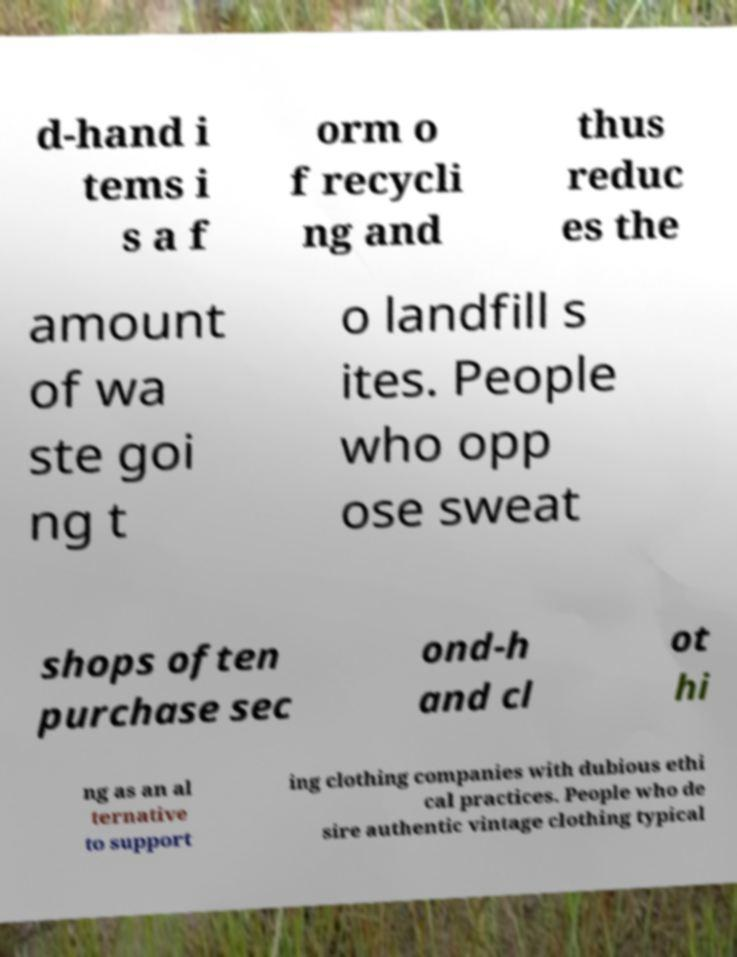Please identify and transcribe the text found in this image. d-hand i tems i s a f orm o f recycli ng and thus reduc es the amount of wa ste goi ng t o landfill s ites. People who opp ose sweat shops often purchase sec ond-h and cl ot hi ng as an al ternative to support ing clothing companies with dubious ethi cal practices. People who de sire authentic vintage clothing typical 